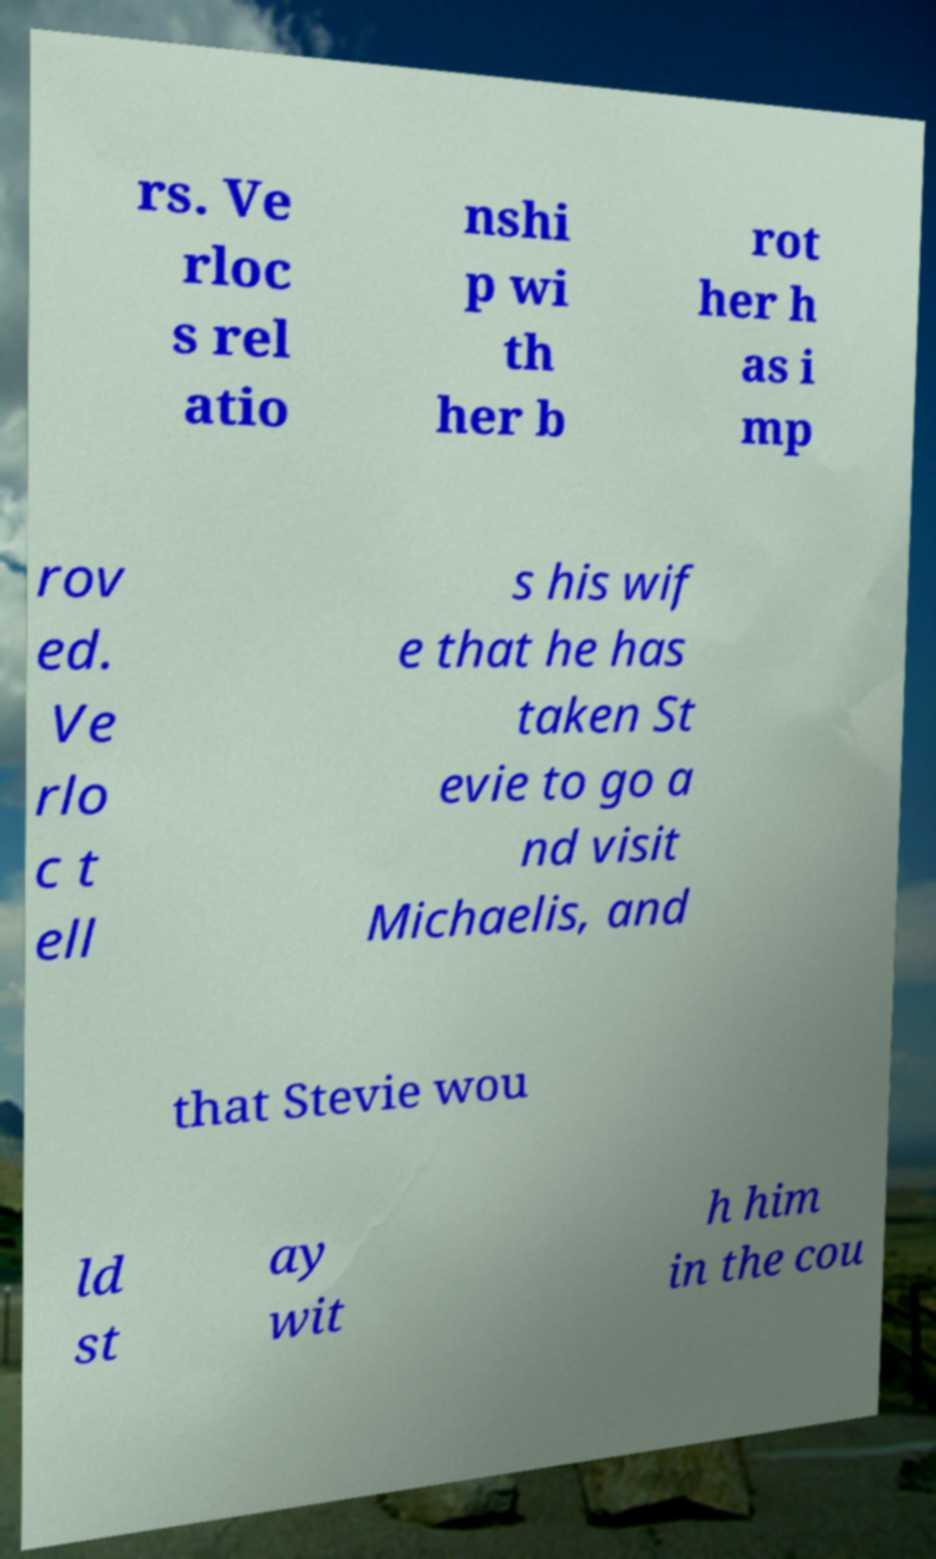Can you read and provide the text displayed in the image?This photo seems to have some interesting text. Can you extract and type it out for me? rs. Ve rloc s rel atio nshi p wi th her b rot her h as i mp rov ed. Ve rlo c t ell s his wif e that he has taken St evie to go a nd visit Michaelis, and that Stevie wou ld st ay wit h him in the cou 